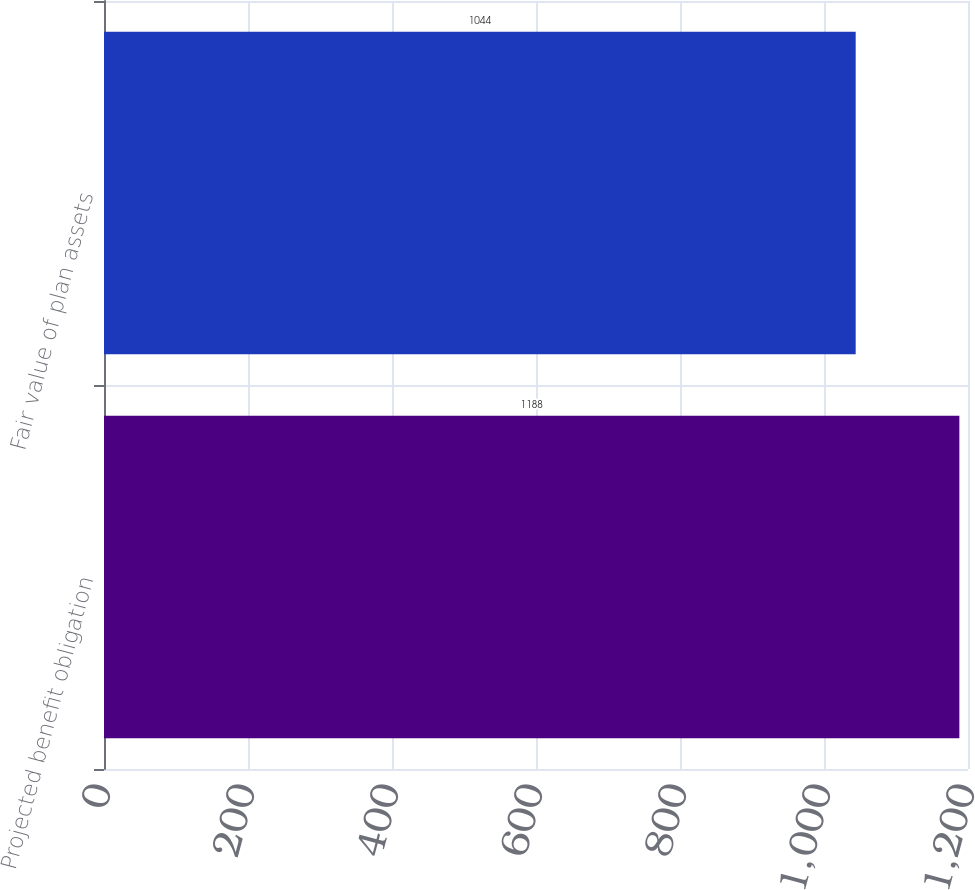Convert chart. <chart><loc_0><loc_0><loc_500><loc_500><bar_chart><fcel>Projected benefit obligation<fcel>Fair value of plan assets<nl><fcel>1188<fcel>1044<nl></chart> 